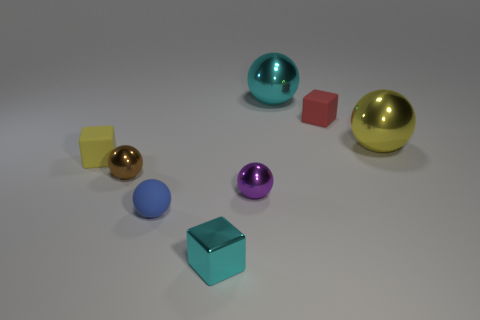Subtract all gray balls. Subtract all cyan cylinders. How many balls are left? 5 Add 2 large cyan objects. How many objects exist? 10 Subtract all spheres. How many objects are left? 3 Add 6 blocks. How many blocks exist? 9 Subtract 1 cyan balls. How many objects are left? 7 Subtract all large spheres. Subtract all tiny brown metallic spheres. How many objects are left? 5 Add 4 yellow rubber cubes. How many yellow rubber cubes are left? 5 